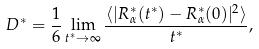Convert formula to latex. <formula><loc_0><loc_0><loc_500><loc_500>D ^ { * } = \frac { 1 } { 6 } \lim _ { t ^ { * } \rightarrow \infty } \frac { \langle | { R } ^ { * } _ { \alpha } ( t ^ { * } ) - { R } ^ { * } _ { \alpha } ( 0 ) | ^ { 2 } \rangle } { t ^ { * } } ,</formula> 